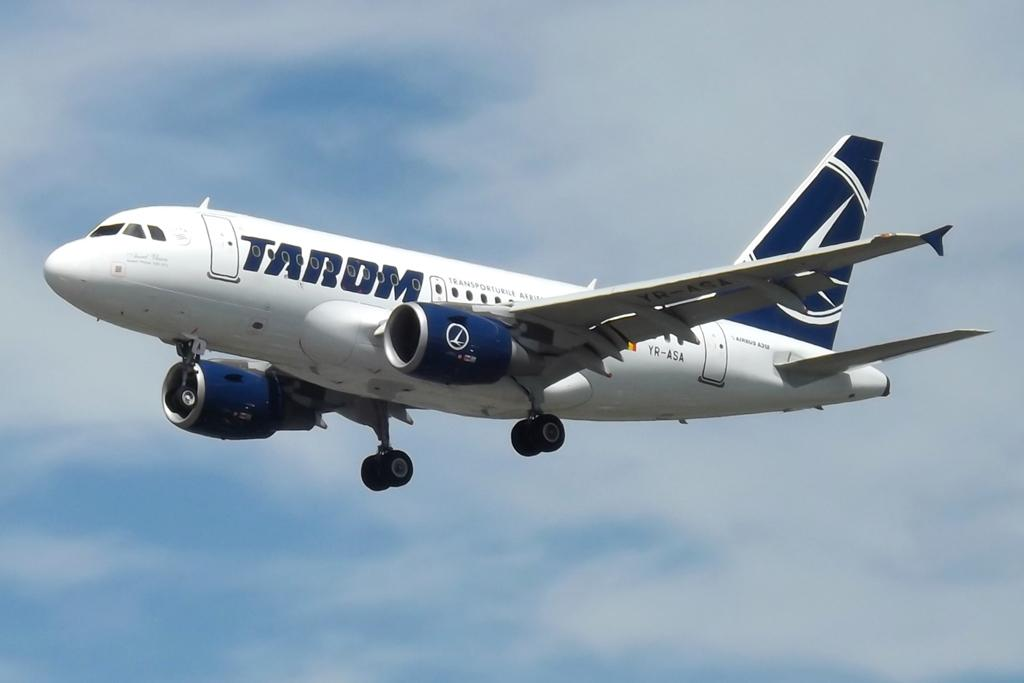Provide a one-sentence caption for the provided image. A TARDM aircraft is flying with its landing gear down. 